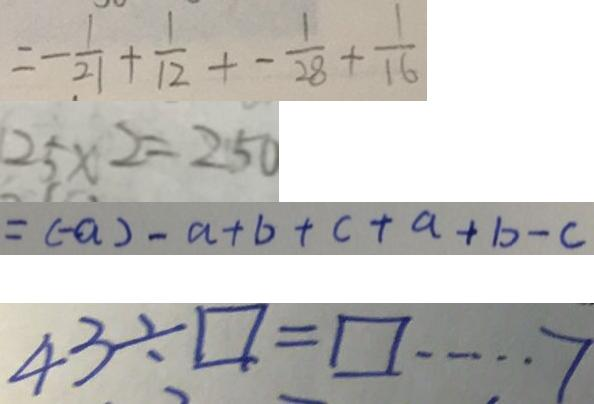Convert formula to latex. <formula><loc_0><loc_0><loc_500><loc_500>= - \frac { 1 } { 2 1 } + \frac { 1 } { 1 2 } + - \frac { 1 } { 2 8 } + \frac { 1 } { 1 6 } 
 2 5 \times 2 = 2 5 0 
 = ( - a ) - a + b + c + a + b - c 
 4 3 \div \square = \square \cdots 7</formula> 